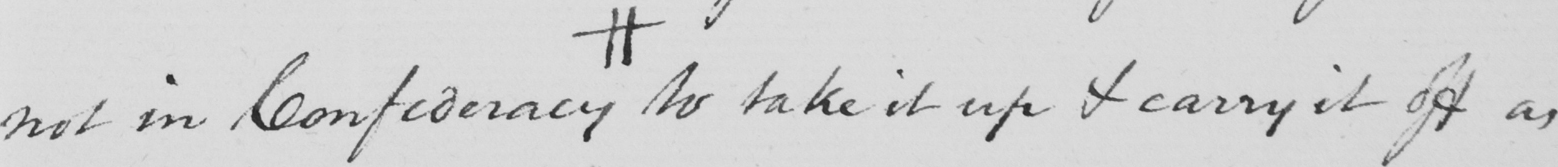Please transcribe the handwritten text in this image. not in Confederacy # to take it up & carry it off as 